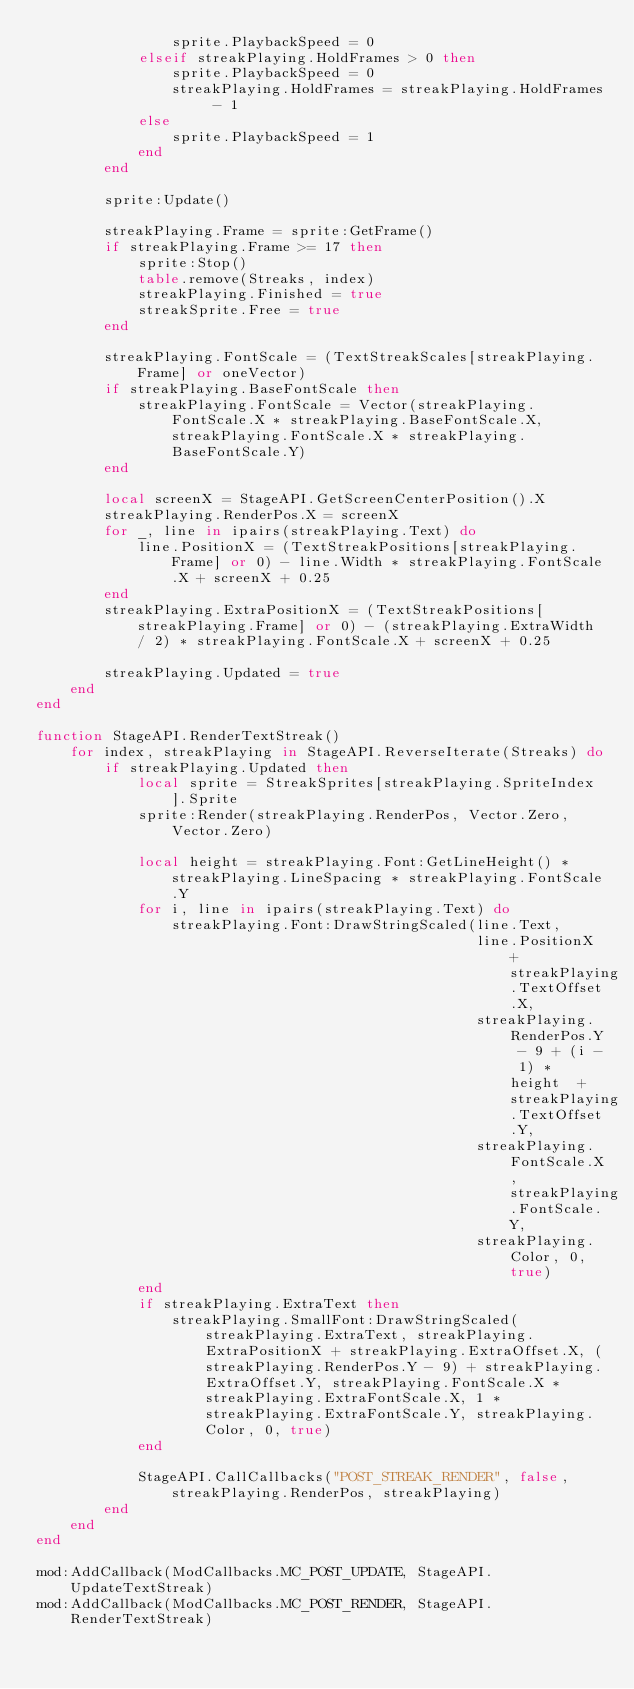<code> <loc_0><loc_0><loc_500><loc_500><_Lua_>                sprite.PlaybackSpeed = 0
            elseif streakPlaying.HoldFrames > 0 then
                sprite.PlaybackSpeed = 0
                streakPlaying.HoldFrames = streakPlaying.HoldFrames - 1
            else
                sprite.PlaybackSpeed = 1
            end
        end

        sprite:Update()

        streakPlaying.Frame = sprite:GetFrame()
        if streakPlaying.Frame >= 17 then
            sprite:Stop()
            table.remove(Streaks, index)
            streakPlaying.Finished = true
            streakSprite.Free = true
        end

        streakPlaying.FontScale = (TextStreakScales[streakPlaying.Frame] or oneVector)
        if streakPlaying.BaseFontScale then
            streakPlaying.FontScale = Vector(streakPlaying.FontScale.X * streakPlaying.BaseFontScale.X, streakPlaying.FontScale.X * streakPlaying.BaseFontScale.Y)
        end

        local screenX = StageAPI.GetScreenCenterPosition().X
        streakPlaying.RenderPos.X = screenX
        for _, line in ipairs(streakPlaying.Text) do
            line.PositionX = (TextStreakPositions[streakPlaying.Frame] or 0) - line.Width * streakPlaying.FontScale.X + screenX + 0.25
        end
        streakPlaying.ExtraPositionX = (TextStreakPositions[streakPlaying.Frame] or 0) - (streakPlaying.ExtraWidth / 2) * streakPlaying.FontScale.X + screenX + 0.25

        streakPlaying.Updated = true
    end
end

function StageAPI.RenderTextStreak()
    for index, streakPlaying in StageAPI.ReverseIterate(Streaks) do
        if streakPlaying.Updated then
            local sprite = StreakSprites[streakPlaying.SpriteIndex].Sprite
            sprite:Render(streakPlaying.RenderPos, Vector.Zero, Vector.Zero)

            local height = streakPlaying.Font:GetLineHeight() * streakPlaying.LineSpacing * streakPlaying.FontScale.Y
            for i, line in ipairs(streakPlaying.Text) do
                streakPlaying.Font:DrawStringScaled(line.Text,
                                                    line.PositionX + streakPlaying.TextOffset.X,
                                                    streakPlaying.RenderPos.Y - 9 + (i - 1) * height  + streakPlaying.TextOffset.Y,
                                                    streakPlaying.FontScale.X, streakPlaying.FontScale.Y,
                                                    streakPlaying.Color, 0, true)
            end
            if streakPlaying.ExtraText then
                streakPlaying.SmallFont:DrawStringScaled(streakPlaying.ExtraText, streakPlaying.ExtraPositionX + streakPlaying.ExtraOffset.X, (streakPlaying.RenderPos.Y - 9) + streakPlaying.ExtraOffset.Y, streakPlaying.FontScale.X * streakPlaying.ExtraFontScale.X, 1 * streakPlaying.ExtraFontScale.Y, streakPlaying.Color, 0, true)
            end

            StageAPI.CallCallbacks("POST_STREAK_RENDER", false, streakPlaying.RenderPos, streakPlaying)
        end
    end
end

mod:AddCallback(ModCallbacks.MC_POST_UPDATE, StageAPI.UpdateTextStreak)
mod:AddCallback(ModCallbacks.MC_POST_RENDER, StageAPI.RenderTextStreak)
</code> 